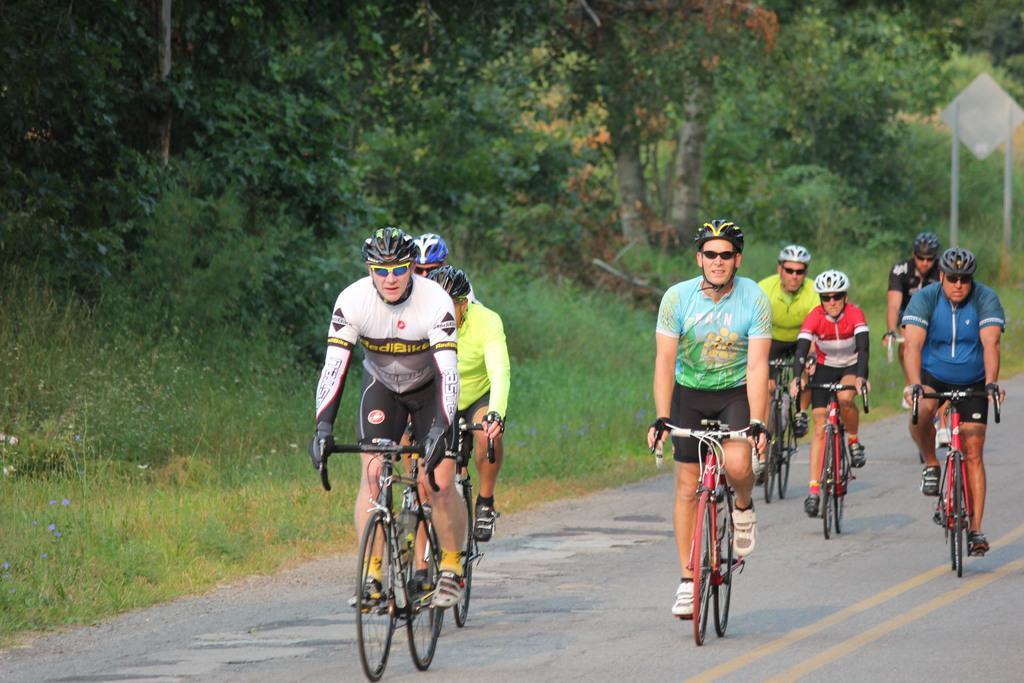Please provide a concise description of this image. In this image I can see there are few persons riding on bi-cycle visible on road, wearing helmets beside them I can see trees, signboard. 